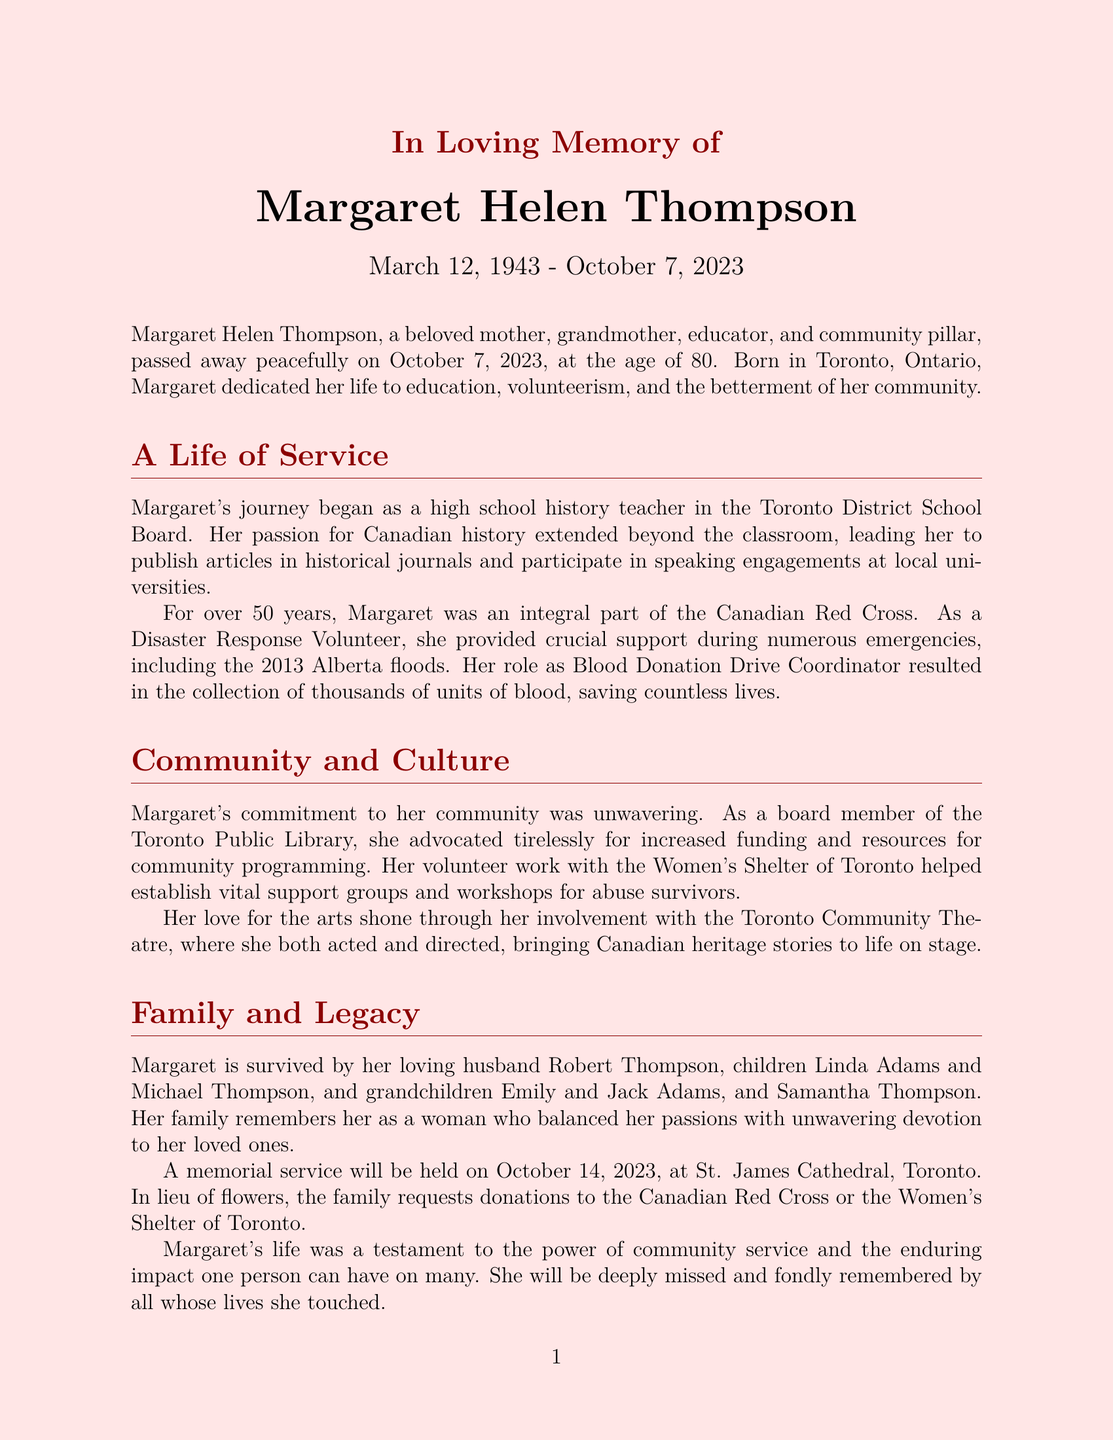What was Margaret's profession? Margaret was a high school history teacher in the Toronto District School Board.
Answer: history teacher When was Margaret born? The document states Margaret was born on March 12, 1943.
Answer: March 12, 1943 How old was Margaret when she passed away? Margaret passed away at the age of 80.
Answer: 80 What organization was Margaret associated with for over 50 years? Margaret was an integral part of the Canadian Red Cross for over 50 years.
Answer: Canadian Red Cross What kind of volunteer work did Margaret do? She was a Disaster Response Volunteer and Blood Donation Drive Coordinator.
Answer: Disaster Response Volunteer and Blood Donation Drive Coordinator Who are two of Margaret's grandchildren? The document names Emily and Jack Adams as grandchildren.
Answer: Emily and Jack Adams What was the location of Margaret's memorial service? The memorial service was held at St. James Cathedral, Toronto.
Answer: St. James Cathedral, Toronto What contributions did Margaret make to the theatre? She was involved with the Toronto Community Theatre as both an actor and director.
Answer: actor and director What did the family request in lieu of flowers? The family requests donations to the Canadian Red Cross or the Women's Shelter of Toronto.
Answer: donations to the Canadian Red Cross or the Women's Shelter of Toronto 